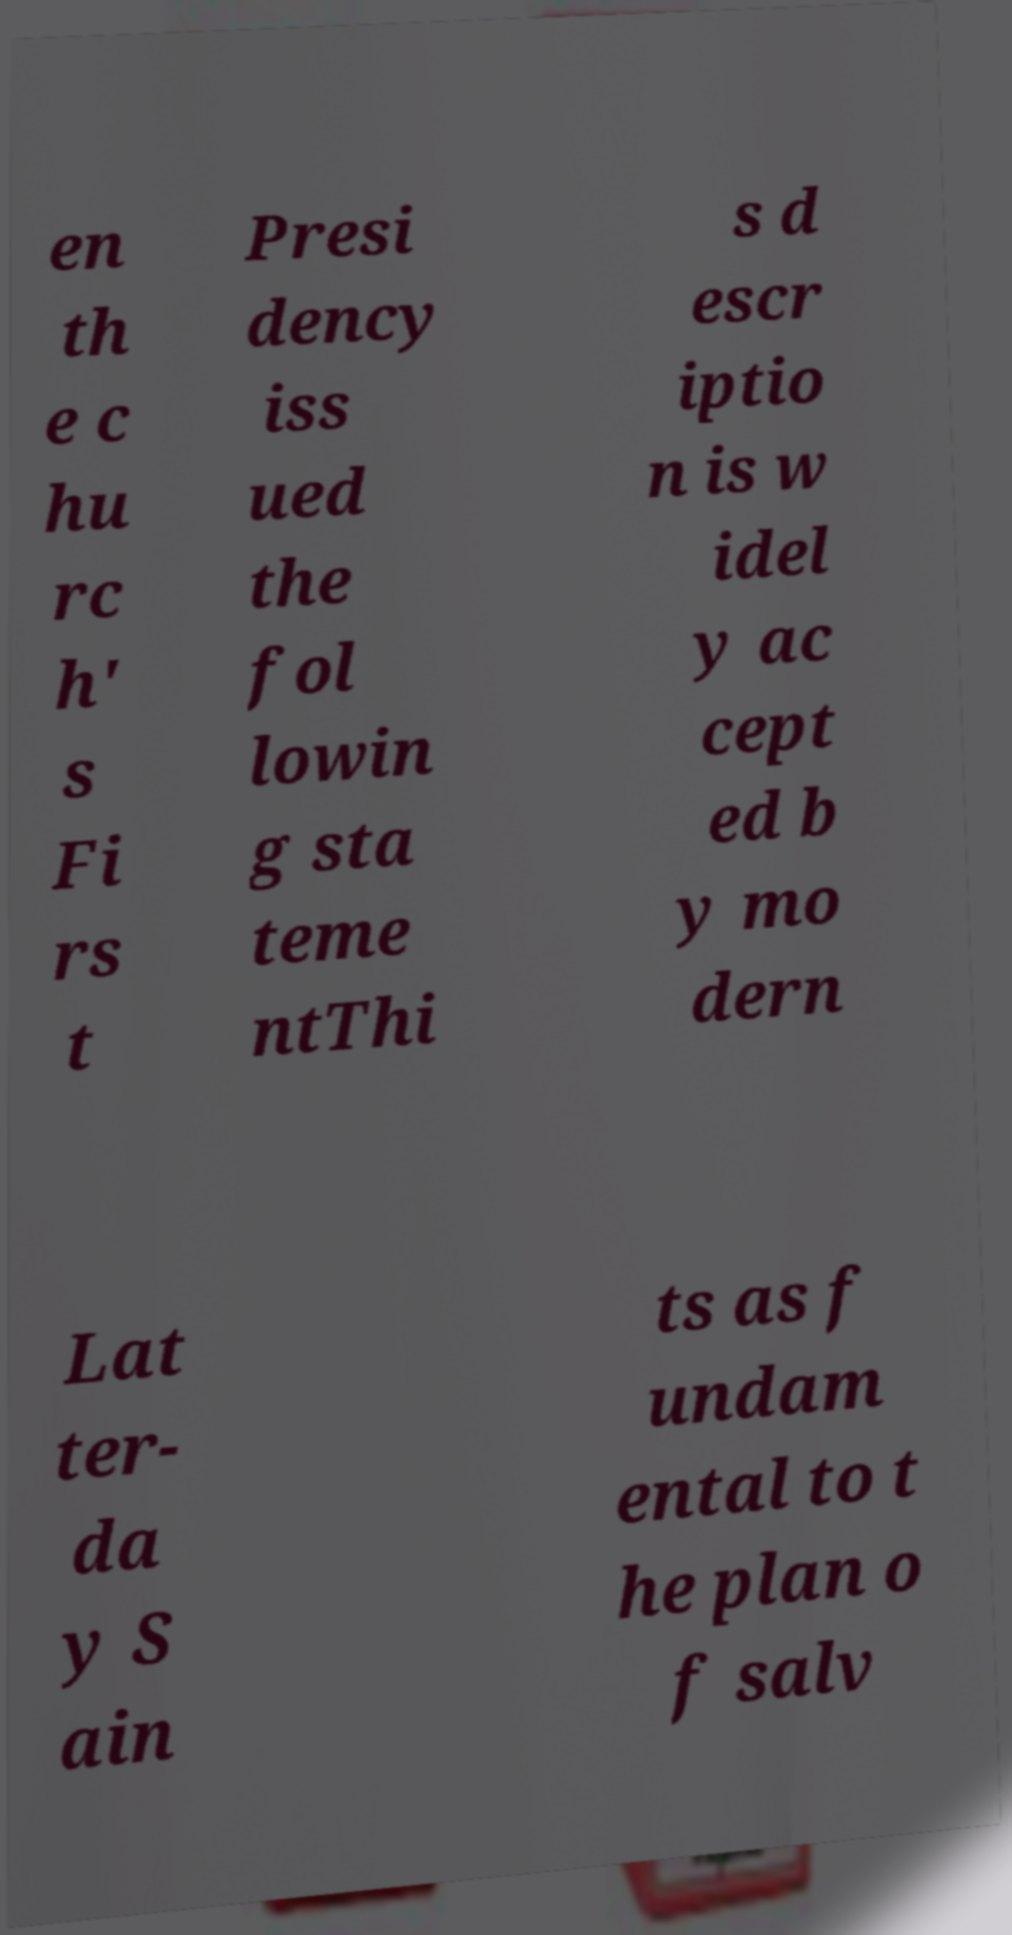I need the written content from this picture converted into text. Can you do that? en th e c hu rc h' s Fi rs t Presi dency iss ued the fol lowin g sta teme ntThi s d escr iptio n is w idel y ac cept ed b y mo dern Lat ter- da y S ain ts as f undam ental to t he plan o f salv 